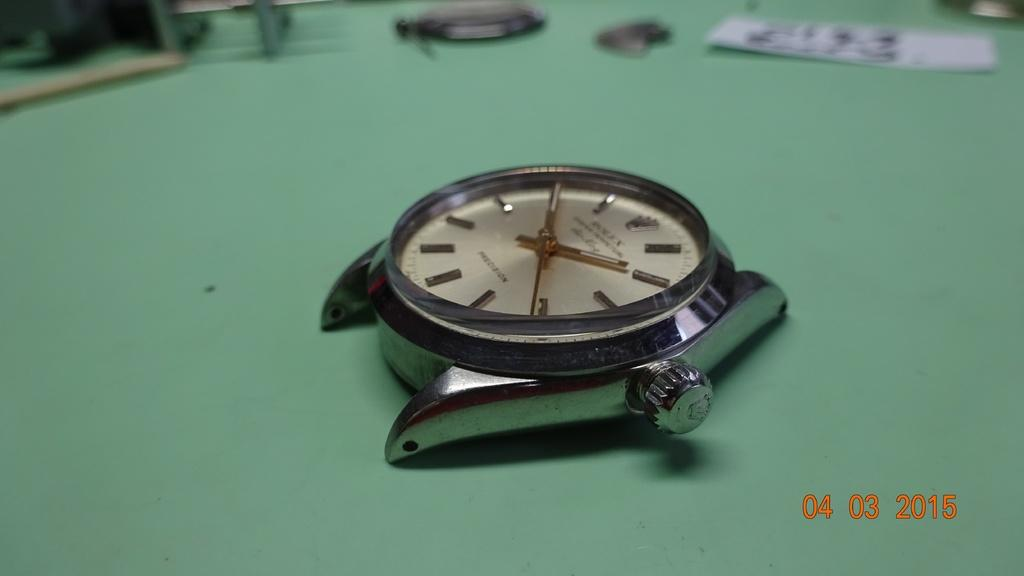What is the main object in the image? There is a watch in the image. What can be seen on the watch dial? There is text on the watch dial. What is located at the top of the image? There are objects at the top of the image. Where are the numbers in the image? The numbers are in the bottom right of the image. Can you tell me how many bushes are growing in the image? There are no bushes present in the image; it features a watch with text on the dial and objects at the top. What type of bird is depicted in the image? There is no bird, such as a turkey, depicted in the image; it features a watch with text on the dial and objects at the top. 